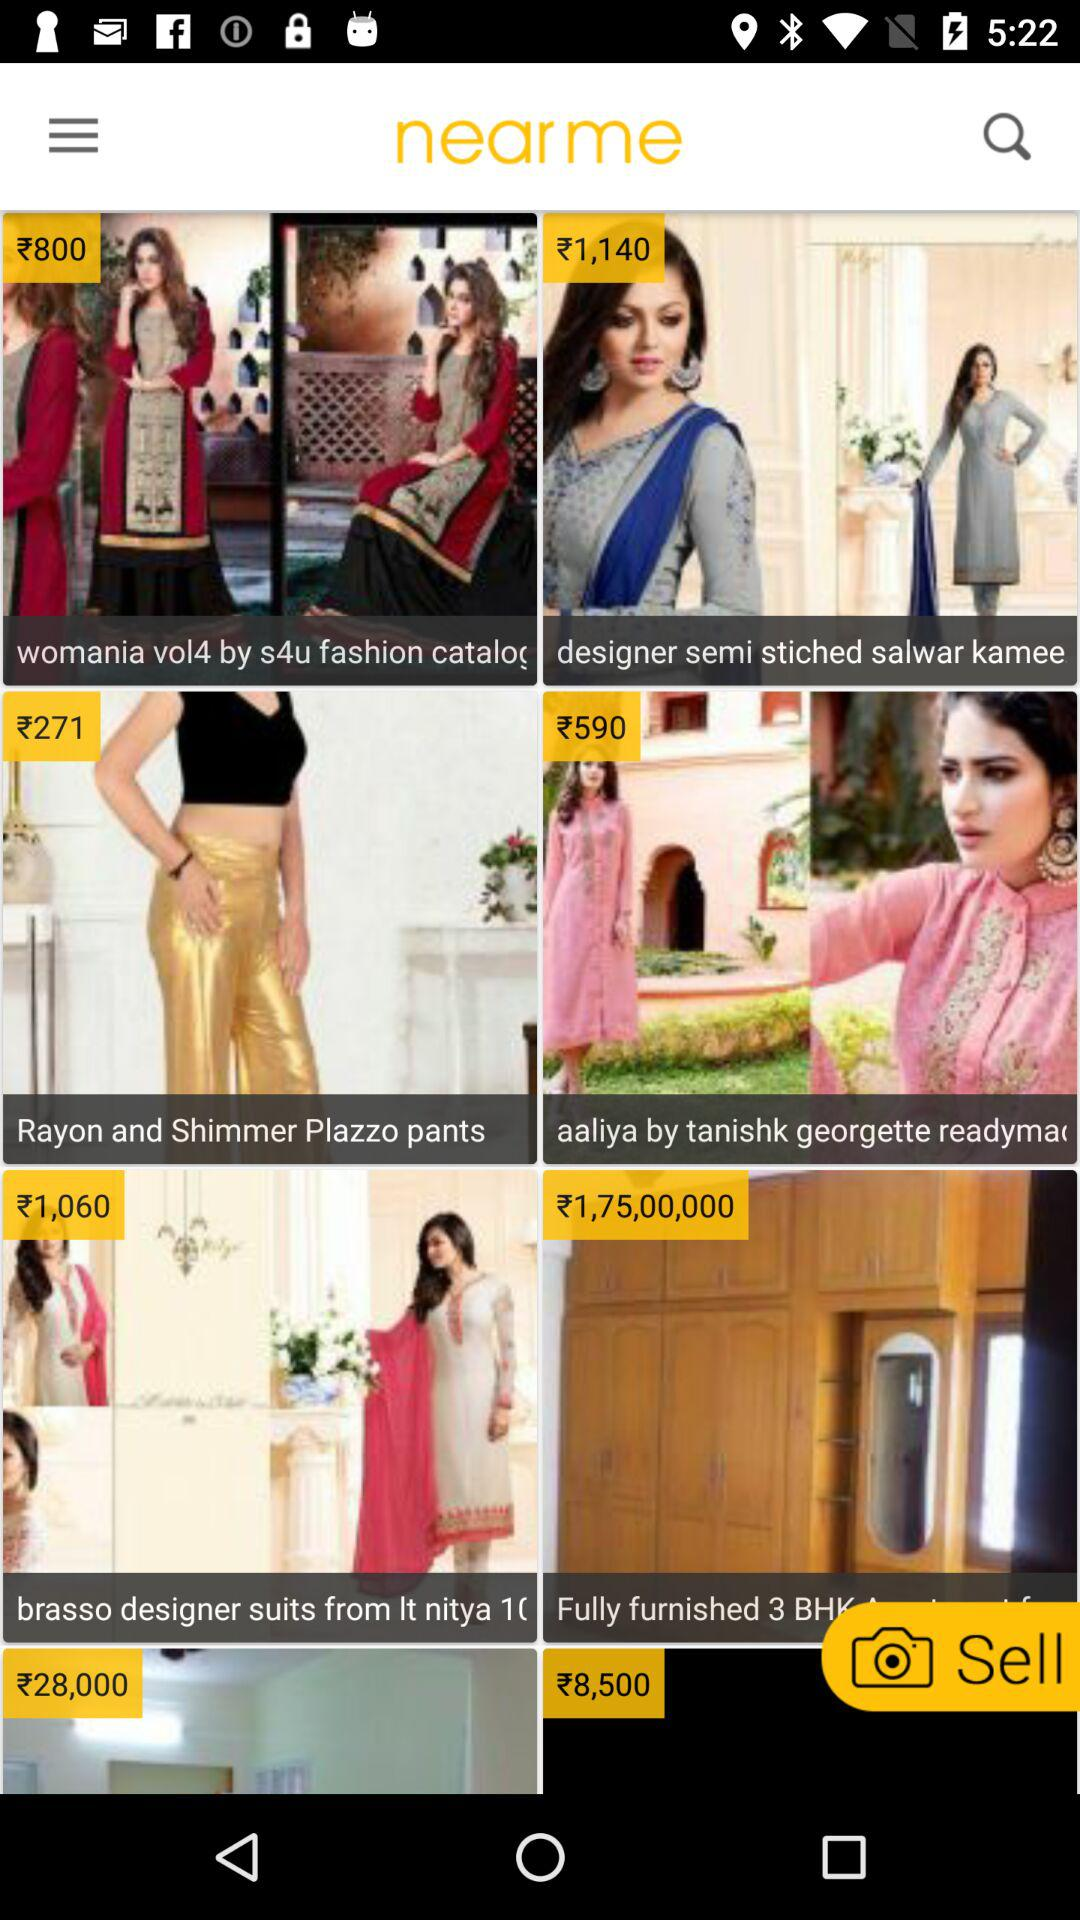What is the price of the "designer semi stiched salwar kamee"? The price of the "designer semi stiched salwar kamee" is ₹1,140. 